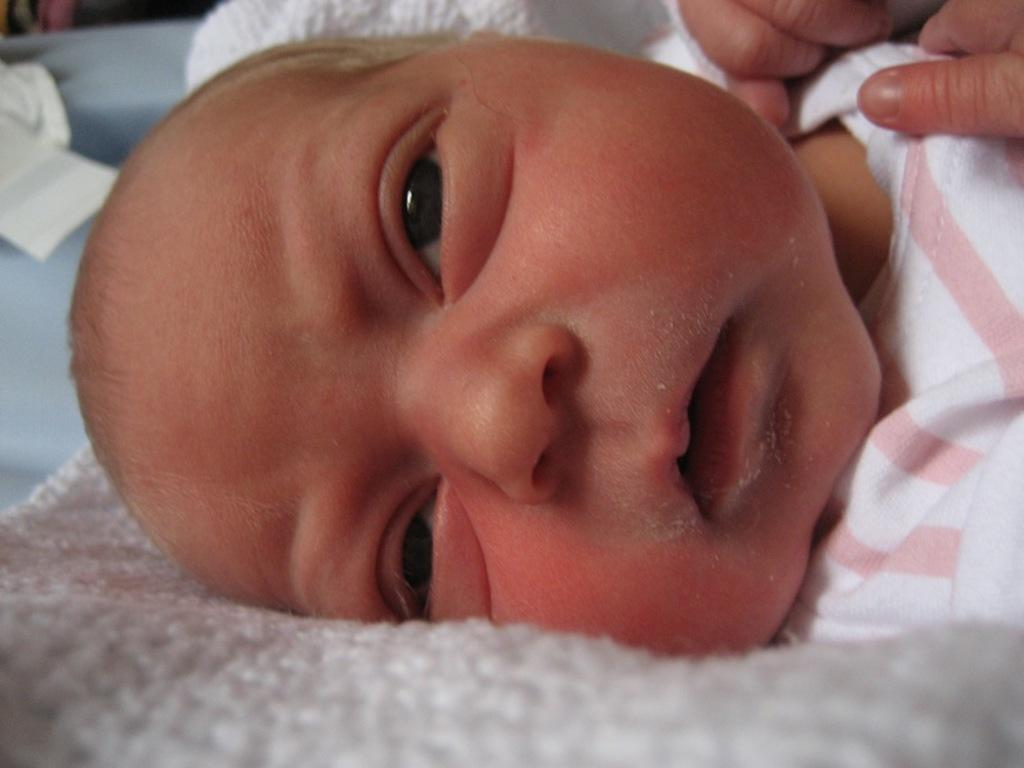What is the main subject of the image? There is a child in the image. Can you describe the child's attire? The child is wearing clothes. What type of knee injury does the child have in the image? There is no indication of a knee injury in the image; the child is simply wearing clothes. What is the child doing with the sink in the image? There is no sink present in the image, and therefore no interaction with a sink can be observed. 